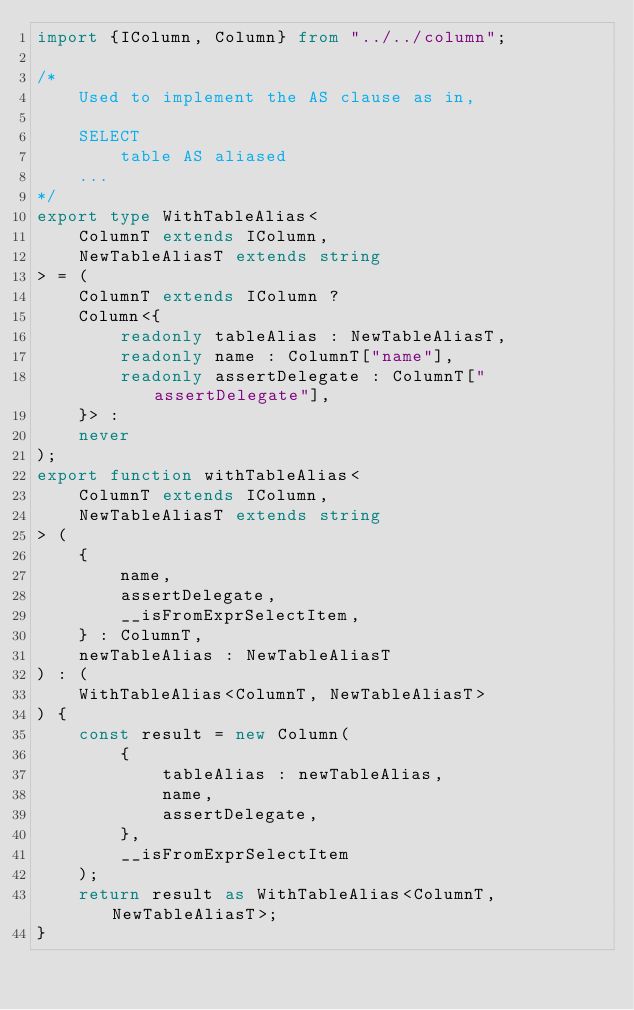Convert code to text. <code><loc_0><loc_0><loc_500><loc_500><_TypeScript_>import {IColumn, Column} from "../../column";

/*
    Used to implement the AS clause as in,

    SELECT
        table AS aliased
    ...
*/
export type WithTableAlias<
    ColumnT extends IColumn,
    NewTableAliasT extends string
> = (
    ColumnT extends IColumn ?
    Column<{
        readonly tableAlias : NewTableAliasT,
        readonly name : ColumnT["name"],
        readonly assertDelegate : ColumnT["assertDelegate"],
    }> :
    never
);
export function withTableAlias<
    ColumnT extends IColumn,
    NewTableAliasT extends string
> (
    {
        name,
        assertDelegate,
        __isFromExprSelectItem,
    } : ColumnT,
    newTableAlias : NewTableAliasT
) : (
    WithTableAlias<ColumnT, NewTableAliasT>
) {
    const result = new Column(
        {
            tableAlias : newTableAlias,
            name,
            assertDelegate,
        },
        __isFromExprSelectItem
    );
    return result as WithTableAlias<ColumnT, NewTableAliasT>;
}
</code> 